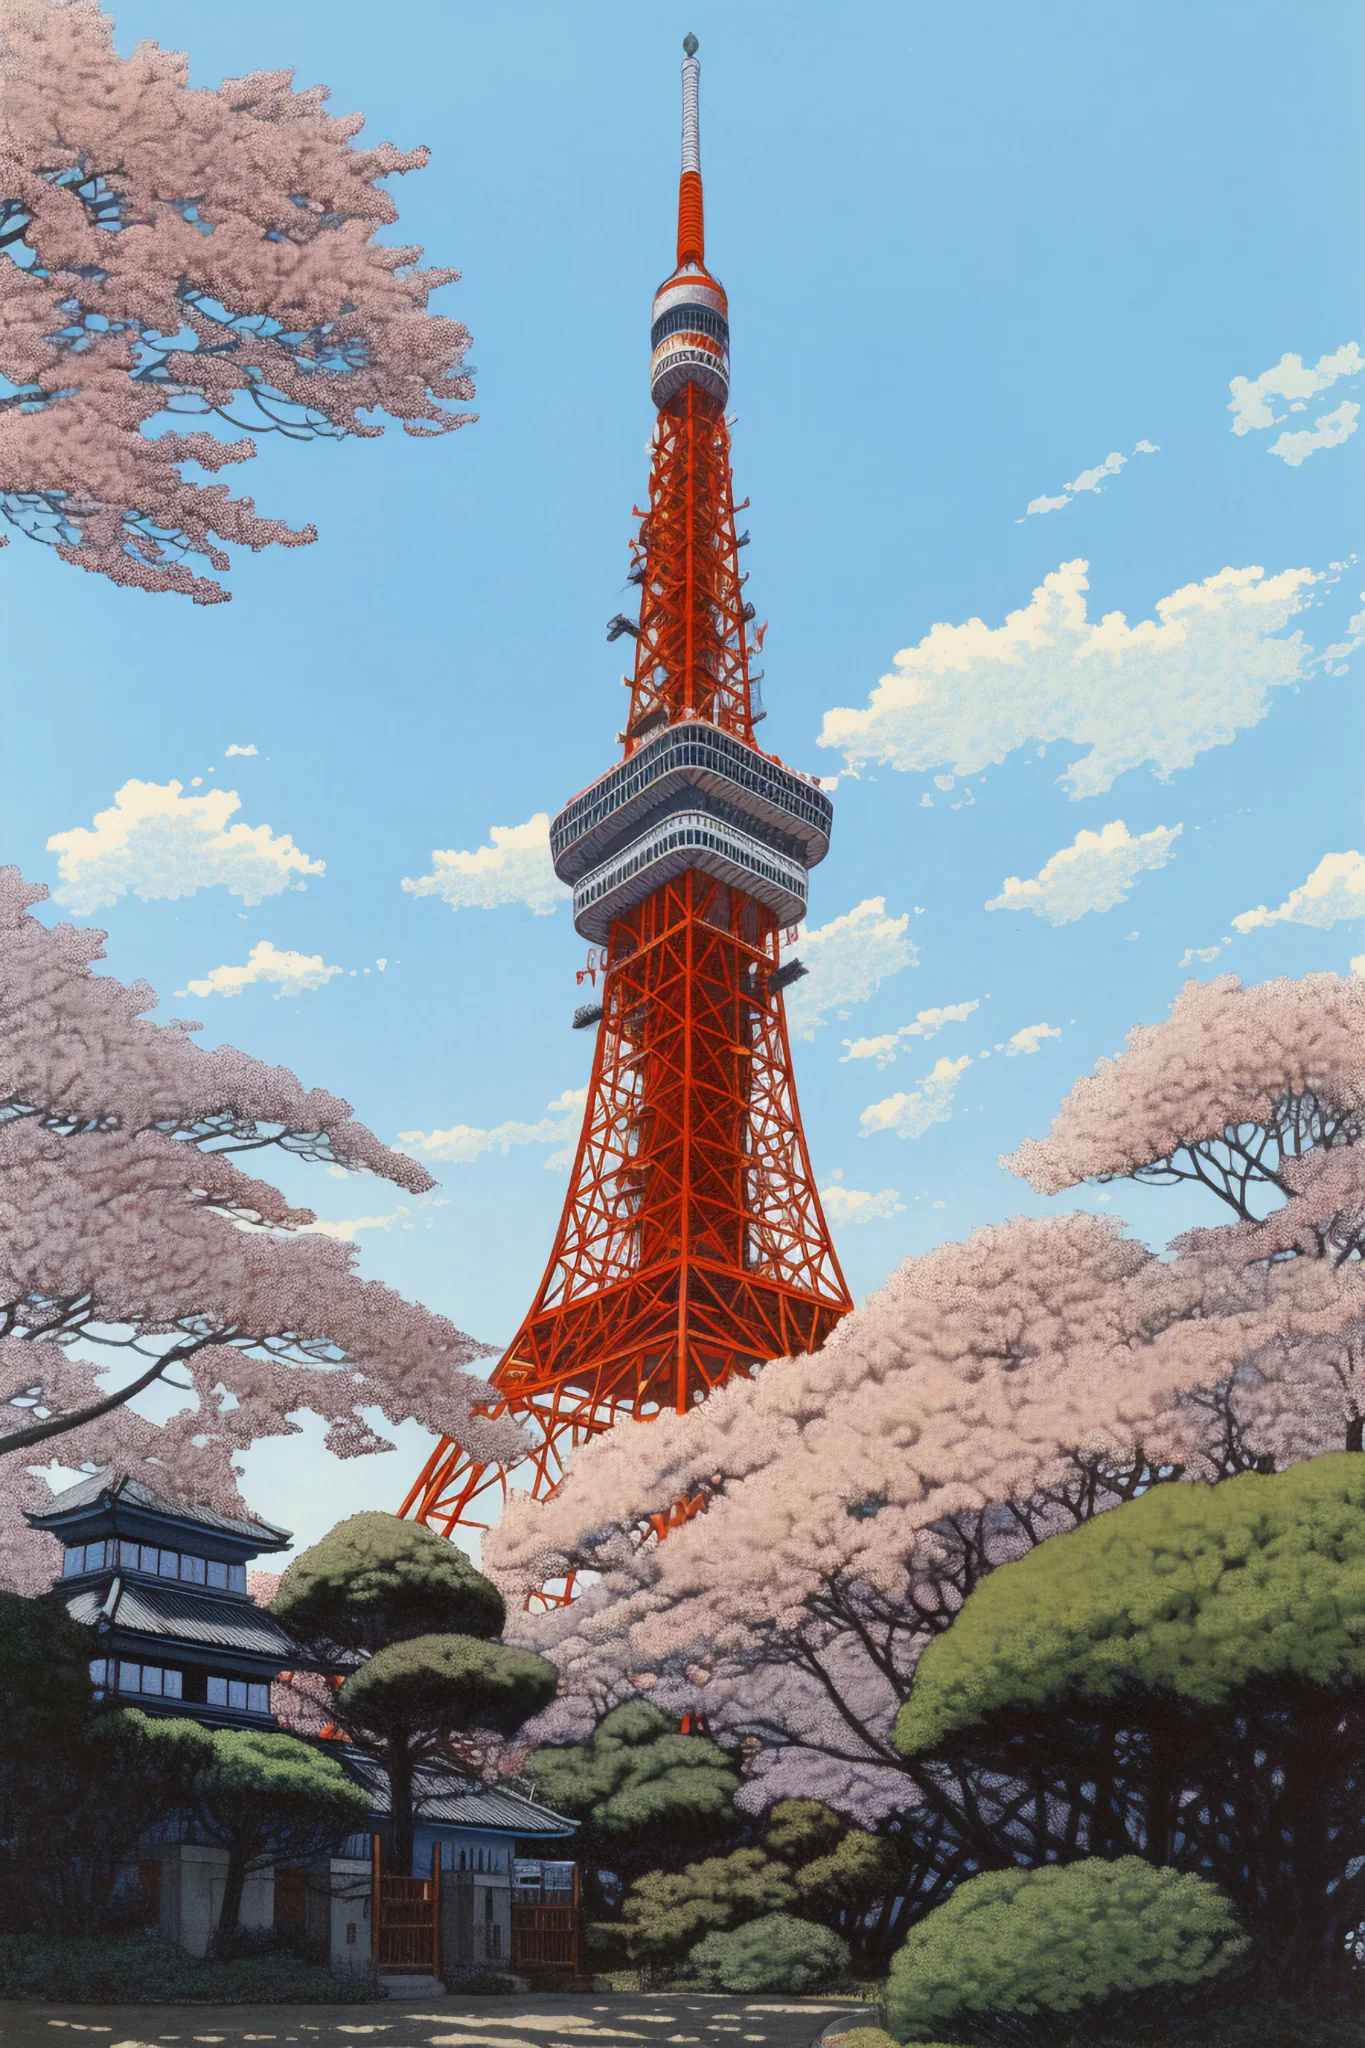If this image was used in a fantasy story, what role would this setting play? In a fantasy narrative, this vibrant scene could serve as the setting for a mystical gateway between the human world and a magical realm. Tokyo Tower, with its luminous orange hue, could be an ancient, enchanted artifact with the ability to open portals. The cherry blossoms might possess secret powers, blooming vibrantly only when the portal is about to open. Characters in the story could gather here to witness the once-in-a-lifetime event where the tower's magic unfolds, ushering them into a fantastical world. What kind of magical creatures might live around this area? Around this enchanted Tokyo Tower, one might encounter ethereal beings such as Sakura Sprites, tiny fairy-like creatures that tend to the cherry blossoms and ensure they bloom each year. There could also be towering, wise, ancient tree spirits that live within the surrounding greenery, sharing their knowledge with those who seek it. The tower itself might be guarded by a majestic Phoenix, its fiery plumage mirroring the tower's bright orange hue, symbolizing rebirth and eternal life. What could be the key conflict in this fantasy story? The core conflict in this fantasy story could revolve around an impending threat from a dark sorcerer who seeks to harness the power of the Tokyo Tower to dominate both the human and magical realms. As the portal opening event nears, the protagonists—a group of unlikely heroes including a young scholar, a seasoned warrior, and a Sakura Sprite—must uncover the ancient secrets of the tower and protect it from falling into his grasp. Along the way, they face various trials, forge powerful alliances, and unveil hidden truths about their own destinies. 